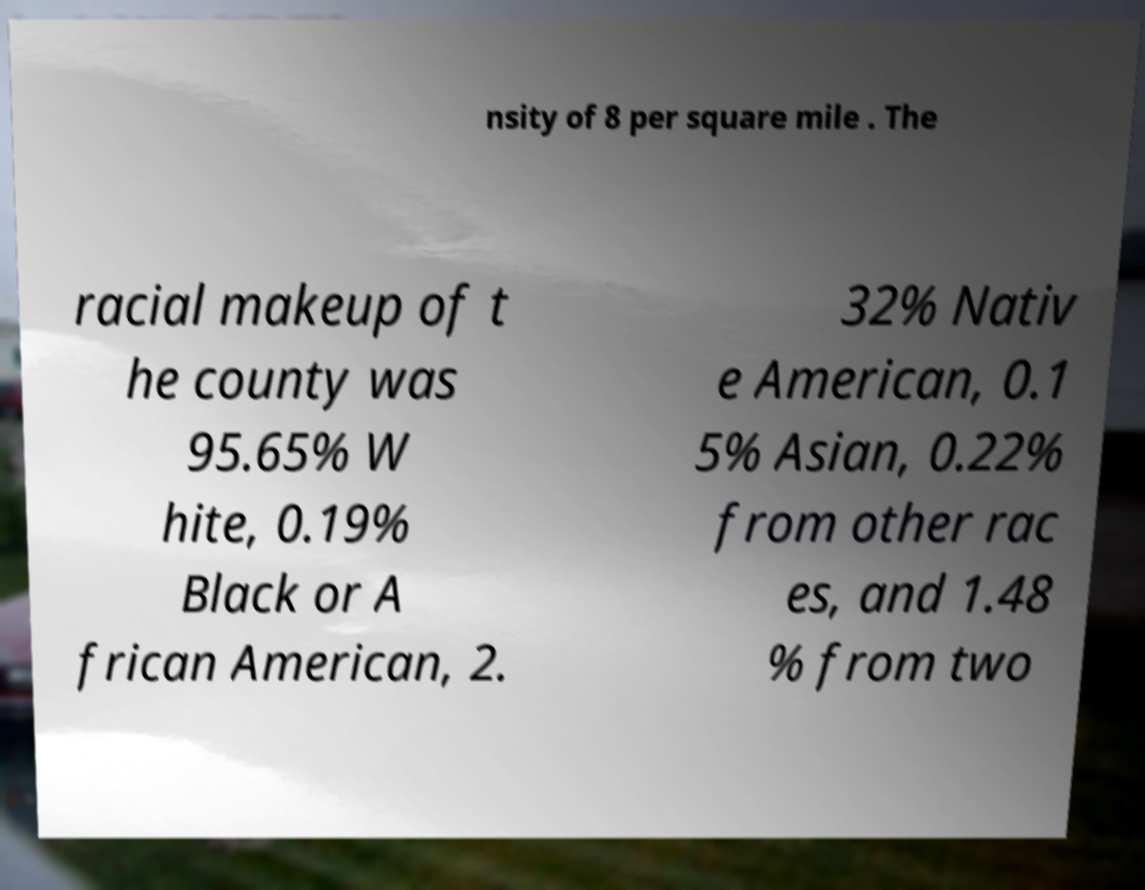Can you read and provide the text displayed in the image?This photo seems to have some interesting text. Can you extract and type it out for me? nsity of 8 per square mile . The racial makeup of t he county was 95.65% W hite, 0.19% Black or A frican American, 2. 32% Nativ e American, 0.1 5% Asian, 0.22% from other rac es, and 1.48 % from two 